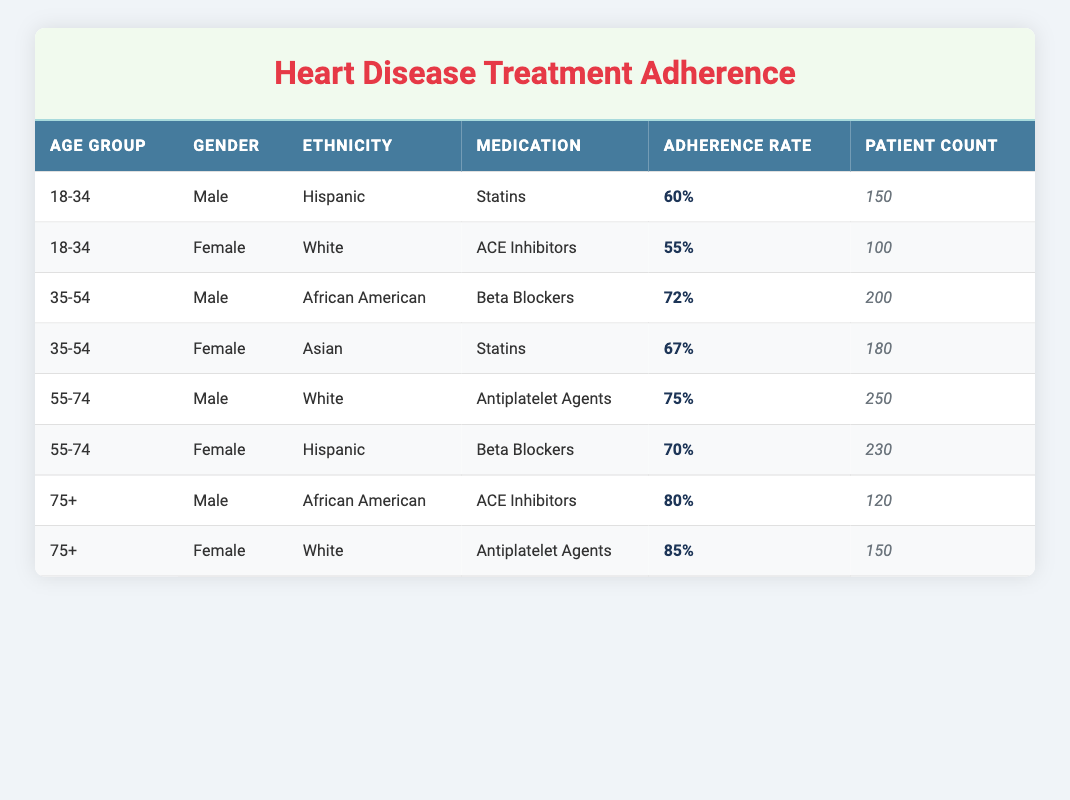What is the adherence rate for females aged 75 and above taking Antiplatelet Agents? The row for females aged 75 and above shows that the adherence rate for Antiplatelet Agents is 85%.
Answer: 85% Which medication has the highest adherence rate among males aged 55-74? Looking at the rows for males aged 55-74, the highest adherence rate is for Antiplatelet Agents at 75%.
Answer: 75% What is the average adherence rate for patients in the age group 35-54? The adherence rates for this age group are 72% (Males, Beta Blockers) and 67% (Females, Statins). The average is calculated as (72 + 67) / 2 = 69.5%.
Answer: 69.5% Are there more patients in the 55-74 age group than in the 75+ age group for females taking Beta Blockers? For females aged 55-74, there are 230 patients taking Beta Blockers, whereas for females aged 75+, there are 150 patients taking Antiplatelet Agents. Therefore, it is true that there are more patients in the 55-74 age group.
Answer: Yes What percentage of patients taking ACE Inhibitors in the 18-34 age group are male? In the 18-34 age group, there are 150 male patients taking Statins and 100 female patients taking ACE Inhibitors. The total number of ACE Inhibitors patients is 100. So, 0/100 = 0% are males.
Answer: 0% What is the total number of patients taking Beta Blockers across all age groups? There are 200 (Males, 35-54) and 230 (Females, 55-74) patients taking Beta Blockers. The total is 200 + 230 = 430 patients.
Answer: 430 Is it true that African American males aged 75 and older have the highest adherence rate for ACE Inhibitors compared to other medications in their demographic? The adherence rate for African American males aged 75 and older taking ACE Inhibitors is 80%. For other demographics, we see varying rates but can't confirm it's the highest without comparing all options. However, it's fairly high.
Answer: Yes How does the adherence rate for Hispanic females aged 55-74 compare to the adherence rate for White females aged 75 and above? The adherence rate for Hispanic females aged 55-74 taking Beta Blockers is 70%, while for White females aged 75 and above taking Antiplatelet Agents, it is 85%. Thus, the White females have a higher adherence rate.
Answer: 85% vs 70% 